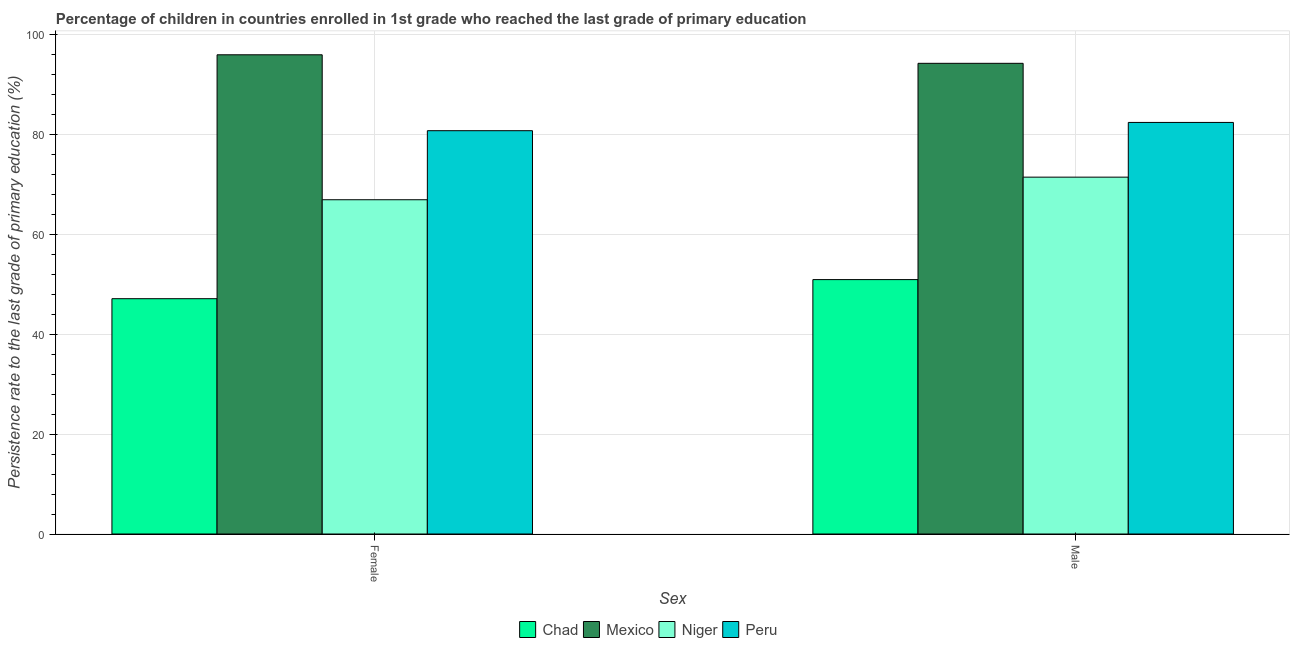How many different coloured bars are there?
Provide a succinct answer. 4. How many groups of bars are there?
Ensure brevity in your answer.  2. What is the persistence rate of female students in Niger?
Keep it short and to the point. 66.87. Across all countries, what is the maximum persistence rate of male students?
Provide a succinct answer. 94.17. Across all countries, what is the minimum persistence rate of male students?
Make the answer very short. 50.9. In which country was the persistence rate of female students maximum?
Give a very brief answer. Mexico. In which country was the persistence rate of female students minimum?
Your response must be concise. Chad. What is the total persistence rate of male students in the graph?
Keep it short and to the point. 298.8. What is the difference between the persistence rate of male students in Mexico and that in Chad?
Ensure brevity in your answer.  43.27. What is the difference between the persistence rate of female students in Chad and the persistence rate of male students in Niger?
Provide a succinct answer. -24.32. What is the average persistence rate of female students per country?
Offer a very short reply. 72.63. What is the difference between the persistence rate of male students and persistence rate of female students in Mexico?
Your answer should be compact. -1.71. What is the ratio of the persistence rate of male students in Niger to that in Chad?
Ensure brevity in your answer.  1.4. Is the persistence rate of female students in Niger less than that in Mexico?
Give a very brief answer. Yes. What does the 3rd bar from the left in Female represents?
Provide a succinct answer. Niger. What does the 3rd bar from the right in Male represents?
Offer a very short reply. Mexico. How many countries are there in the graph?
Give a very brief answer. 4. Are the values on the major ticks of Y-axis written in scientific E-notation?
Keep it short and to the point. No. Does the graph contain any zero values?
Offer a very short reply. No. Where does the legend appear in the graph?
Provide a short and direct response. Bottom center. What is the title of the graph?
Offer a terse response. Percentage of children in countries enrolled in 1st grade who reached the last grade of primary education. What is the label or title of the X-axis?
Your answer should be compact. Sex. What is the label or title of the Y-axis?
Your response must be concise. Persistence rate to the last grade of primary education (%). What is the Persistence rate to the last grade of primary education (%) of Chad in Female?
Your answer should be very brief. 47.08. What is the Persistence rate to the last grade of primary education (%) of Mexico in Female?
Your response must be concise. 95.88. What is the Persistence rate to the last grade of primary education (%) of Niger in Female?
Give a very brief answer. 66.87. What is the Persistence rate to the last grade of primary education (%) of Peru in Female?
Make the answer very short. 80.69. What is the Persistence rate to the last grade of primary education (%) of Chad in Male?
Offer a very short reply. 50.9. What is the Persistence rate to the last grade of primary education (%) in Mexico in Male?
Offer a terse response. 94.17. What is the Persistence rate to the last grade of primary education (%) in Niger in Male?
Your answer should be very brief. 71.39. What is the Persistence rate to the last grade of primary education (%) of Peru in Male?
Offer a terse response. 82.34. Across all Sex, what is the maximum Persistence rate to the last grade of primary education (%) in Chad?
Give a very brief answer. 50.9. Across all Sex, what is the maximum Persistence rate to the last grade of primary education (%) in Mexico?
Your answer should be compact. 95.88. Across all Sex, what is the maximum Persistence rate to the last grade of primary education (%) of Niger?
Ensure brevity in your answer.  71.39. Across all Sex, what is the maximum Persistence rate to the last grade of primary education (%) in Peru?
Make the answer very short. 82.34. Across all Sex, what is the minimum Persistence rate to the last grade of primary education (%) in Chad?
Offer a very short reply. 47.08. Across all Sex, what is the minimum Persistence rate to the last grade of primary education (%) of Mexico?
Provide a succinct answer. 94.17. Across all Sex, what is the minimum Persistence rate to the last grade of primary education (%) in Niger?
Provide a short and direct response. 66.87. Across all Sex, what is the minimum Persistence rate to the last grade of primary education (%) of Peru?
Offer a very short reply. 80.69. What is the total Persistence rate to the last grade of primary education (%) in Chad in the graph?
Offer a very short reply. 97.98. What is the total Persistence rate to the last grade of primary education (%) in Mexico in the graph?
Your answer should be compact. 190.04. What is the total Persistence rate to the last grade of primary education (%) of Niger in the graph?
Your response must be concise. 138.27. What is the total Persistence rate to the last grade of primary education (%) of Peru in the graph?
Offer a terse response. 163.03. What is the difference between the Persistence rate to the last grade of primary education (%) of Chad in Female and that in Male?
Make the answer very short. -3.82. What is the difference between the Persistence rate to the last grade of primary education (%) in Mexico in Female and that in Male?
Give a very brief answer. 1.71. What is the difference between the Persistence rate to the last grade of primary education (%) in Niger in Female and that in Male?
Offer a very short reply. -4.52. What is the difference between the Persistence rate to the last grade of primary education (%) of Peru in Female and that in Male?
Your answer should be very brief. -1.65. What is the difference between the Persistence rate to the last grade of primary education (%) of Chad in Female and the Persistence rate to the last grade of primary education (%) of Mexico in Male?
Offer a terse response. -47.09. What is the difference between the Persistence rate to the last grade of primary education (%) in Chad in Female and the Persistence rate to the last grade of primary education (%) in Niger in Male?
Make the answer very short. -24.32. What is the difference between the Persistence rate to the last grade of primary education (%) of Chad in Female and the Persistence rate to the last grade of primary education (%) of Peru in Male?
Give a very brief answer. -35.26. What is the difference between the Persistence rate to the last grade of primary education (%) of Mexico in Female and the Persistence rate to the last grade of primary education (%) of Niger in Male?
Offer a terse response. 24.48. What is the difference between the Persistence rate to the last grade of primary education (%) in Mexico in Female and the Persistence rate to the last grade of primary education (%) in Peru in Male?
Make the answer very short. 13.53. What is the difference between the Persistence rate to the last grade of primary education (%) in Niger in Female and the Persistence rate to the last grade of primary education (%) in Peru in Male?
Your answer should be compact. -15.47. What is the average Persistence rate to the last grade of primary education (%) of Chad per Sex?
Give a very brief answer. 48.99. What is the average Persistence rate to the last grade of primary education (%) in Mexico per Sex?
Make the answer very short. 95.02. What is the average Persistence rate to the last grade of primary education (%) of Niger per Sex?
Make the answer very short. 69.13. What is the average Persistence rate to the last grade of primary education (%) in Peru per Sex?
Provide a succinct answer. 81.51. What is the difference between the Persistence rate to the last grade of primary education (%) of Chad and Persistence rate to the last grade of primary education (%) of Mexico in Female?
Give a very brief answer. -48.8. What is the difference between the Persistence rate to the last grade of primary education (%) of Chad and Persistence rate to the last grade of primary education (%) of Niger in Female?
Offer a terse response. -19.79. What is the difference between the Persistence rate to the last grade of primary education (%) in Chad and Persistence rate to the last grade of primary education (%) in Peru in Female?
Your response must be concise. -33.61. What is the difference between the Persistence rate to the last grade of primary education (%) in Mexico and Persistence rate to the last grade of primary education (%) in Niger in Female?
Keep it short and to the point. 29. What is the difference between the Persistence rate to the last grade of primary education (%) in Mexico and Persistence rate to the last grade of primary education (%) in Peru in Female?
Give a very brief answer. 15.19. What is the difference between the Persistence rate to the last grade of primary education (%) in Niger and Persistence rate to the last grade of primary education (%) in Peru in Female?
Keep it short and to the point. -13.81. What is the difference between the Persistence rate to the last grade of primary education (%) of Chad and Persistence rate to the last grade of primary education (%) of Mexico in Male?
Give a very brief answer. -43.27. What is the difference between the Persistence rate to the last grade of primary education (%) of Chad and Persistence rate to the last grade of primary education (%) of Niger in Male?
Offer a terse response. -20.5. What is the difference between the Persistence rate to the last grade of primary education (%) of Chad and Persistence rate to the last grade of primary education (%) of Peru in Male?
Provide a succinct answer. -31.44. What is the difference between the Persistence rate to the last grade of primary education (%) of Mexico and Persistence rate to the last grade of primary education (%) of Niger in Male?
Your answer should be compact. 22.77. What is the difference between the Persistence rate to the last grade of primary education (%) in Mexico and Persistence rate to the last grade of primary education (%) in Peru in Male?
Make the answer very short. 11.83. What is the difference between the Persistence rate to the last grade of primary education (%) in Niger and Persistence rate to the last grade of primary education (%) in Peru in Male?
Your answer should be very brief. -10.95. What is the ratio of the Persistence rate to the last grade of primary education (%) in Chad in Female to that in Male?
Give a very brief answer. 0.93. What is the ratio of the Persistence rate to the last grade of primary education (%) in Mexico in Female to that in Male?
Keep it short and to the point. 1.02. What is the ratio of the Persistence rate to the last grade of primary education (%) in Niger in Female to that in Male?
Make the answer very short. 0.94. What is the ratio of the Persistence rate to the last grade of primary education (%) in Peru in Female to that in Male?
Ensure brevity in your answer.  0.98. What is the difference between the highest and the second highest Persistence rate to the last grade of primary education (%) of Chad?
Your answer should be very brief. 3.82. What is the difference between the highest and the second highest Persistence rate to the last grade of primary education (%) in Mexico?
Offer a very short reply. 1.71. What is the difference between the highest and the second highest Persistence rate to the last grade of primary education (%) of Niger?
Offer a terse response. 4.52. What is the difference between the highest and the second highest Persistence rate to the last grade of primary education (%) of Peru?
Provide a succinct answer. 1.65. What is the difference between the highest and the lowest Persistence rate to the last grade of primary education (%) of Chad?
Offer a terse response. 3.82. What is the difference between the highest and the lowest Persistence rate to the last grade of primary education (%) in Mexico?
Offer a terse response. 1.71. What is the difference between the highest and the lowest Persistence rate to the last grade of primary education (%) in Niger?
Keep it short and to the point. 4.52. What is the difference between the highest and the lowest Persistence rate to the last grade of primary education (%) of Peru?
Give a very brief answer. 1.65. 